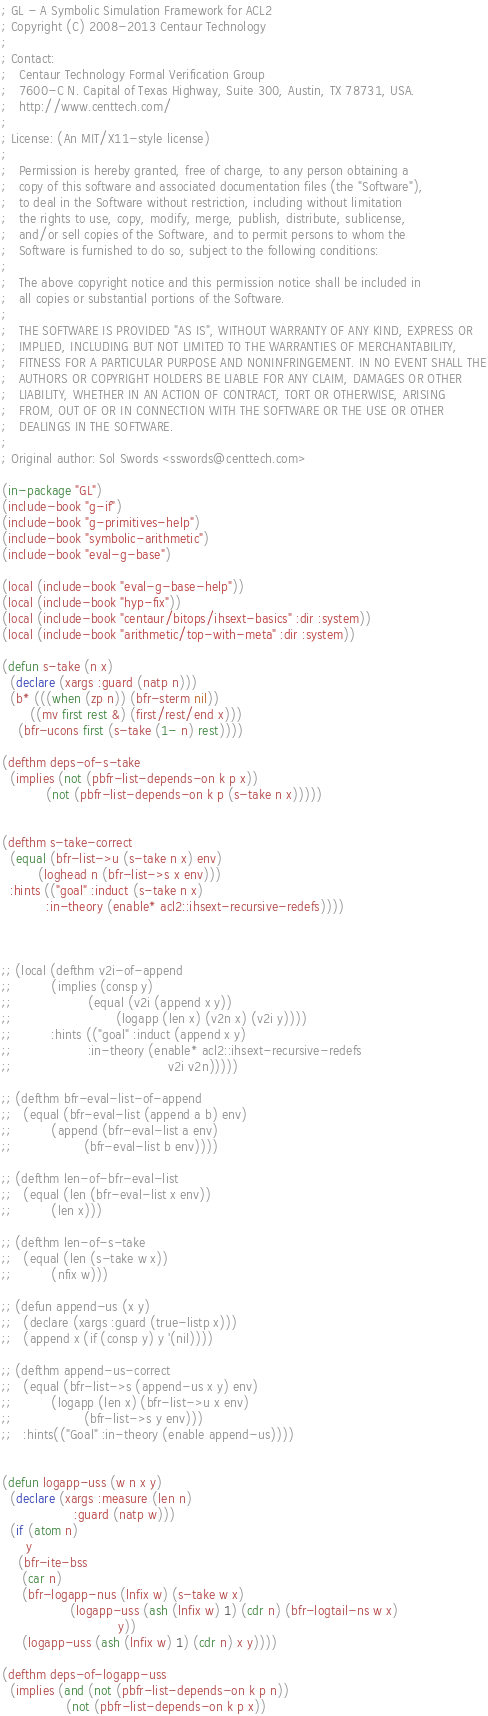<code> <loc_0><loc_0><loc_500><loc_500><_Lisp_>; GL - A Symbolic Simulation Framework for ACL2
; Copyright (C) 2008-2013 Centaur Technology
;
; Contact:
;   Centaur Technology Formal Verification Group
;   7600-C N. Capital of Texas Highway, Suite 300, Austin, TX 78731, USA.
;   http://www.centtech.com/
;
; License: (An MIT/X11-style license)
;
;   Permission is hereby granted, free of charge, to any person obtaining a
;   copy of this software and associated documentation files (the "Software"),
;   to deal in the Software without restriction, including without limitation
;   the rights to use, copy, modify, merge, publish, distribute, sublicense,
;   and/or sell copies of the Software, and to permit persons to whom the
;   Software is furnished to do so, subject to the following conditions:
;
;   The above copyright notice and this permission notice shall be included in
;   all copies or substantial portions of the Software.
;
;   THE SOFTWARE IS PROVIDED "AS IS", WITHOUT WARRANTY OF ANY KIND, EXPRESS OR
;   IMPLIED, INCLUDING BUT NOT LIMITED TO THE WARRANTIES OF MERCHANTABILITY,
;   FITNESS FOR A PARTICULAR PURPOSE AND NONINFRINGEMENT. IN NO EVENT SHALL THE
;   AUTHORS OR COPYRIGHT HOLDERS BE LIABLE FOR ANY CLAIM, DAMAGES OR OTHER
;   LIABILITY, WHETHER IN AN ACTION OF CONTRACT, TORT OR OTHERWISE, ARISING
;   FROM, OUT OF OR IN CONNECTION WITH THE SOFTWARE OR THE USE OR OTHER
;   DEALINGS IN THE SOFTWARE.
;
; Original author: Sol Swords <sswords@centtech.com>

(in-package "GL")
(include-book "g-if")
(include-book "g-primitives-help")
(include-book "symbolic-arithmetic")
(include-book "eval-g-base")

(local (include-book "eval-g-base-help"))
(local (include-book "hyp-fix"))
(local (include-book "centaur/bitops/ihsext-basics" :dir :system))
(local (include-book "arithmetic/top-with-meta" :dir :system))

(defun s-take (n x)
  (declare (xargs :guard (natp n)))
  (b* (((when (zp n)) (bfr-sterm nil))
       ((mv first rest &) (first/rest/end x)))
    (bfr-ucons first (s-take (1- n) rest))))

(defthm deps-of-s-take
  (implies (not (pbfr-list-depends-on k p x))
           (not (pbfr-list-depends-on k p (s-take n x)))))


(defthm s-take-correct
  (equal (bfr-list->u (s-take n x) env)
         (loghead n (bfr-list->s x env)))
  :hints (("goal" :induct (s-take n x)
           :in-theory (enable* acl2::ihsext-recursive-redefs))))



;; (local (defthm v2i-of-append
;;          (implies (consp y)
;;                   (equal (v2i (append x y))
;;                          (logapp (len x) (v2n x) (v2i y))))
;;          :hints (("goal" :induct (append x y)
;;                   :in-theory (enable* acl2::ihsext-recursive-redefs
;;                                       v2i v2n)))))

;; (defthm bfr-eval-list-of-append
;;   (equal (bfr-eval-list (append a b) env)
;;          (append (bfr-eval-list a env)
;;                  (bfr-eval-list b env))))

;; (defthm len-of-bfr-eval-list
;;   (equal (len (bfr-eval-list x env))
;;          (len x)))

;; (defthm len-of-s-take
;;   (equal (len (s-take w x))
;;          (nfix w)))

;; (defun append-us (x y)
;;   (declare (xargs :guard (true-listp x)))
;;   (append x (if (consp y) y '(nil))))

;; (defthm append-us-correct
;;   (equal (bfr-list->s (append-us x y) env)
;;          (logapp (len x) (bfr-list->u x env)
;;                  (bfr-list->s y env)))
;;   :hints(("Goal" :in-theory (enable append-us))))


(defun logapp-uss (w n x y)
  (declare (xargs :measure (len n)
                  :guard (natp w)))
  (if (atom n)
      y
    (bfr-ite-bss
     (car n)
     (bfr-logapp-nus (lnfix w) (s-take w x)
                 (logapp-uss (ash (lnfix w) 1) (cdr n) (bfr-logtail-ns w x)
                             y))
     (logapp-uss (ash (lnfix w) 1) (cdr n) x y))))

(defthm deps-of-logapp-uss
  (implies (and (not (pbfr-list-depends-on k p n))
                (not (pbfr-list-depends-on k p x))</code> 